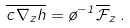<formula> <loc_0><loc_0><loc_500><loc_500>\overline { c \nabla _ { z } h } = \tau ^ { - 1 } \overline { \mathcal { F } } _ { z } \, .</formula> 